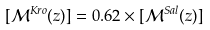Convert formula to latex. <formula><loc_0><loc_0><loc_500><loc_500>[ \mathcal { M } ^ { K r o } ( z ) ] = 0 . 6 2 \times [ \mathcal { M } ^ { S a l } ( z ) ]</formula> 